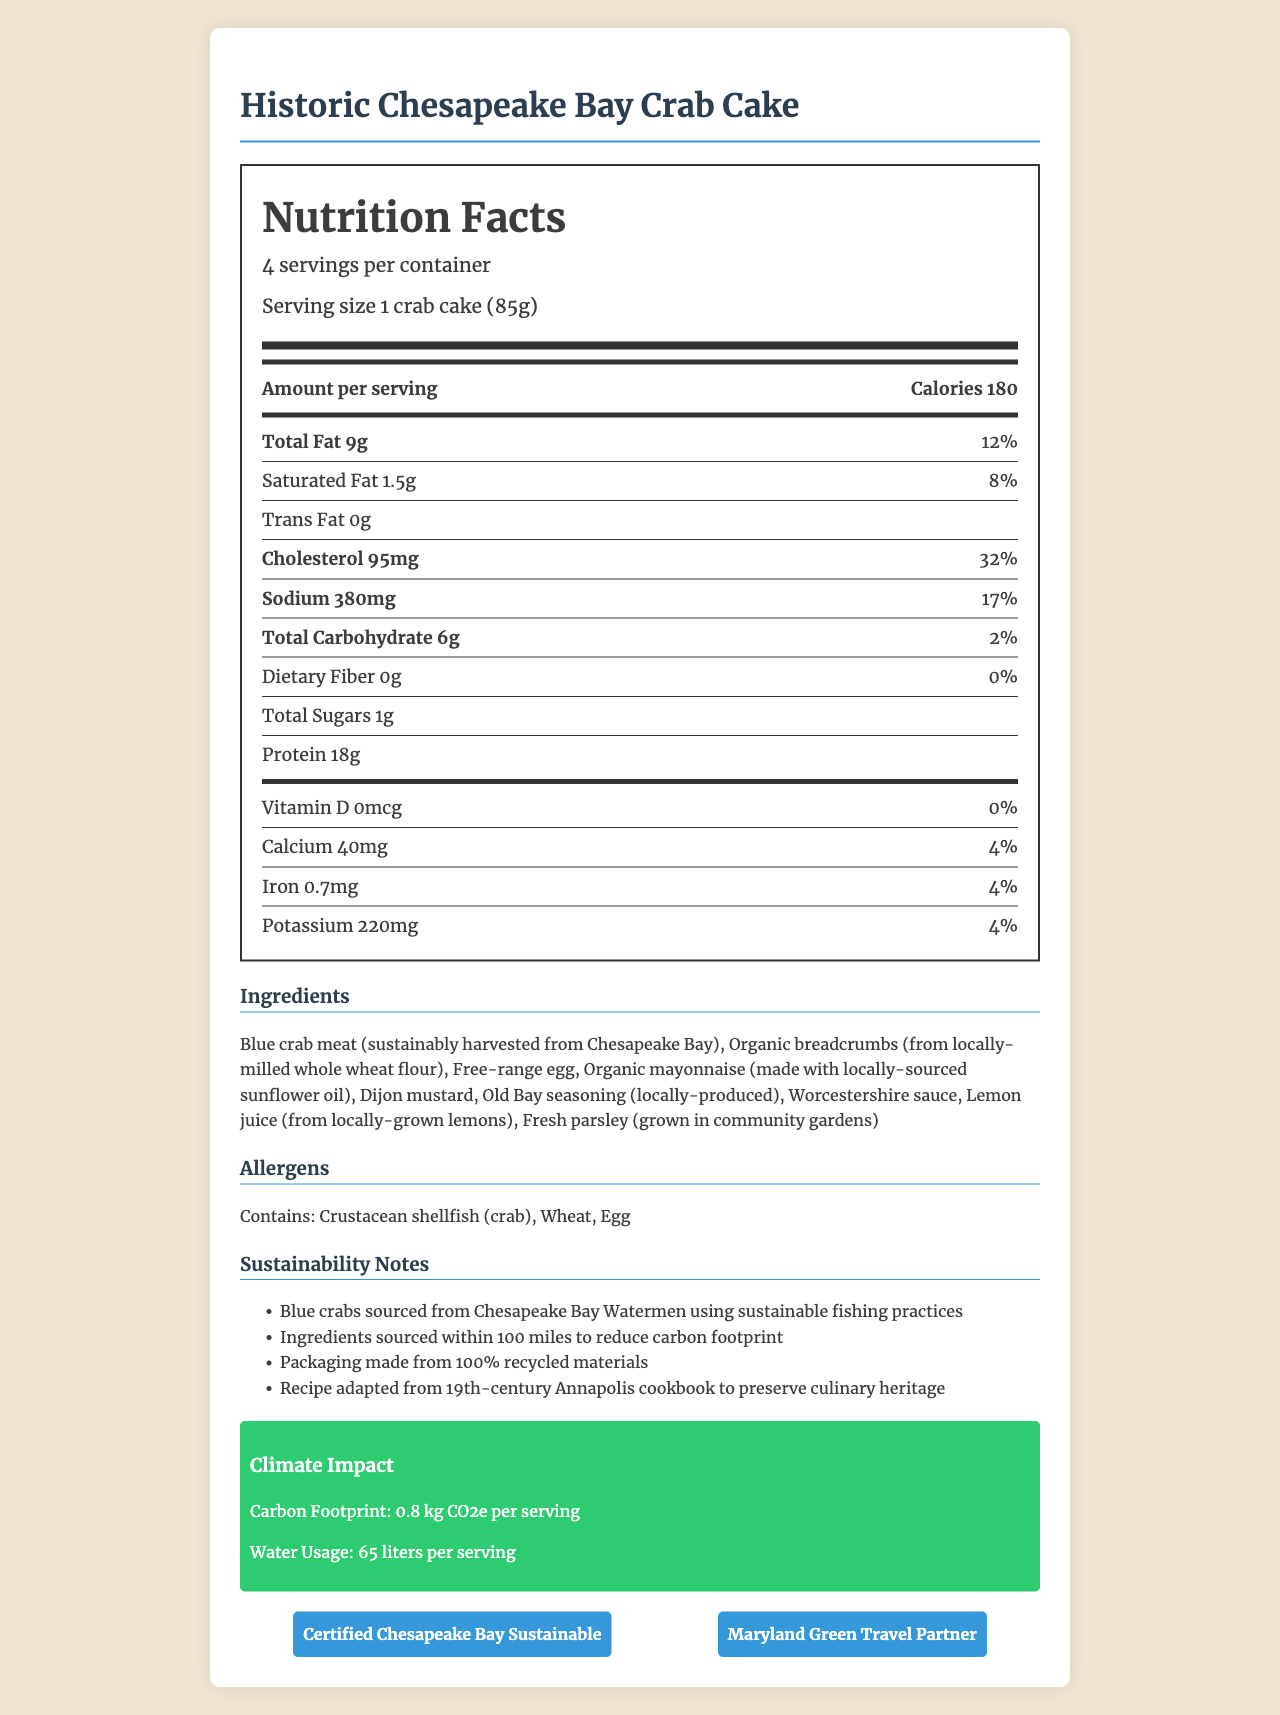How many servings per container are provided by the Historic Chesapeake Bay Crab Cake? The document specifies that there are 4 servings per container.
Answer: 4 What is the serving size of the Historic Chesapeake Bay Crab Cake? The document states that the serving size is 1 crab cake weighing 85 grams.
Answer: 1 crab cake (85g) How many calories are in one serving of the Historic Chesapeake Bay Crab Cake? The document indicates that one serving contains 180 calories.
Answer: 180 What percentage of the daily value for sodium is in one serving? The document lists that one serving contains 17% of the daily value for sodium.
Answer: 17% Which ingredient in the crab cake is likely responsible for the 32% daily value of cholesterol? Given that shellfish are typically high in cholesterol, it is likely that the blue crab meat contributes most to the 32% daily value.
Answer: Blue crab meat How much protein is in one serving of the crab cake? The document states that there are 18 grams of protein per serving.
Answer: 18g How is the crab used in the recipe sourced? A. From an international supplier B. Sustainably harvested from Chesapeake Bay C. Farm-raised The document states that the blue crab meat is sustainably harvested from Chesapeake Bay.
Answer: B What sustainable practice is followed in sourcing the ingredients? A. Imported from different countries B. Produced in nearby states C. Sourced within 100 miles The document mentions that the ingredients are sourced within 100 miles to reduce carbon footprint.
Answer: C Does the product contain any added sugars? The document shows that there are 0 grams of added sugars per serving.
Answer: No What is the carbon footprint per serving of the crab cake? The document specifies that the carbon footprint is 0.8 kg CO2e per serving.
Answer: 0.8 kg CO2e per serving What certification does the crab cake have for sustainability? A. Certified Chesapeake Bay Sustainable B. Ocean Wise C. Marine Stewardship Council Certified The document lists the certification as "Certified Chesapeake Bay Sustainable."
Answer: A Is the allergen information available in the document? The document provides allergen information, stating it contains crustacean shellfish (crab), wheat, and egg.
Answer: Yes Summarize the main idea of the document. The document details nutritional content and sustainability practices for the crab cakes, emphasizing locally-sourced and environmentally friendly ingredients.
Answer: The document provides complete nutrition information for the Historic Chesapeake Bay Crab Cake, including serving sizes, daily values, ingredients, allergens, sustainability notes, climate impact, and certifications. It highlights the use of locally-sourced, sustainable ingredients and traditional recipes adapted from historical cookbooks. What is the water usage per serving of the crab cake? The document specifies that each serving uses 65 liters of water.
Answer: 65 liters per serving What is the daily value percentage of dietary fiber in one serving? The document states that one serving contains 0% of the daily value for dietary fiber.
Answer: 0% Can we determine the cooking method for the crab cake from the document? The document does not provide any details about how the crab cake is cooked.
Answer: Not enough information What is the main fat source in the crab cakes, considering the ingredient list provided? The document mentions organic mayonnaise as an ingredient, which is typically high in fat.
Answer: Organic mayonnaise (made with locally-sourced sunflower oil) 